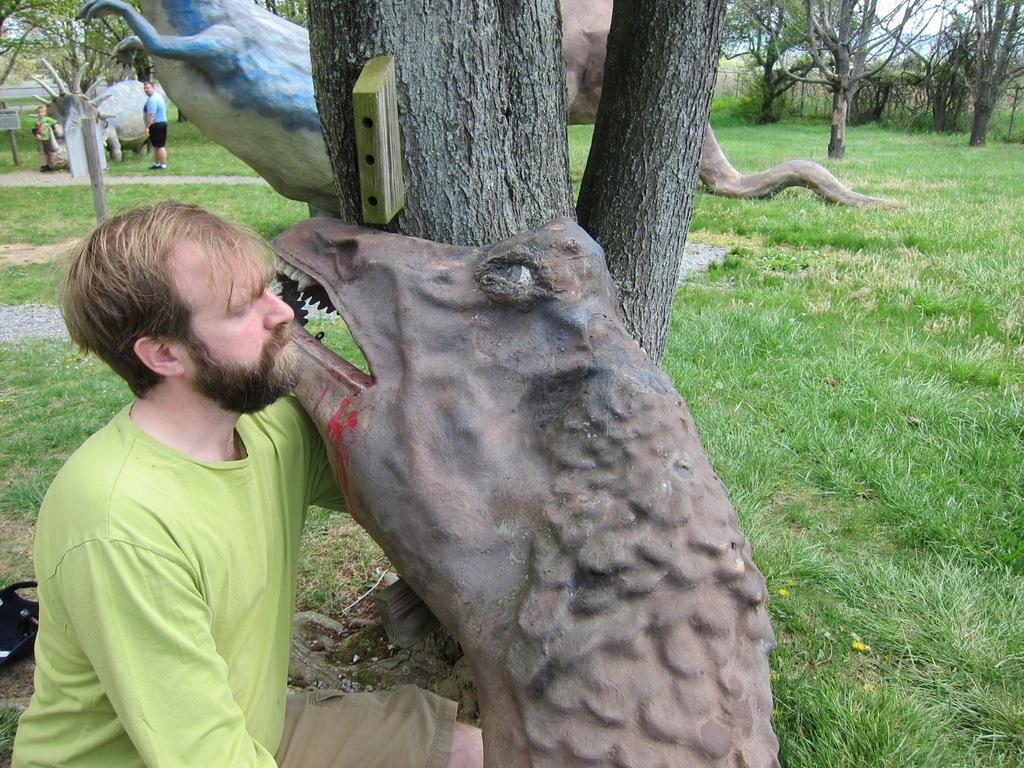How would you summarize this image in a sentence or two? In this image, we can see a man sitting beside the statue, there are some statues, we can see some people standing, there is green grass on the ground and we can see some trees. 